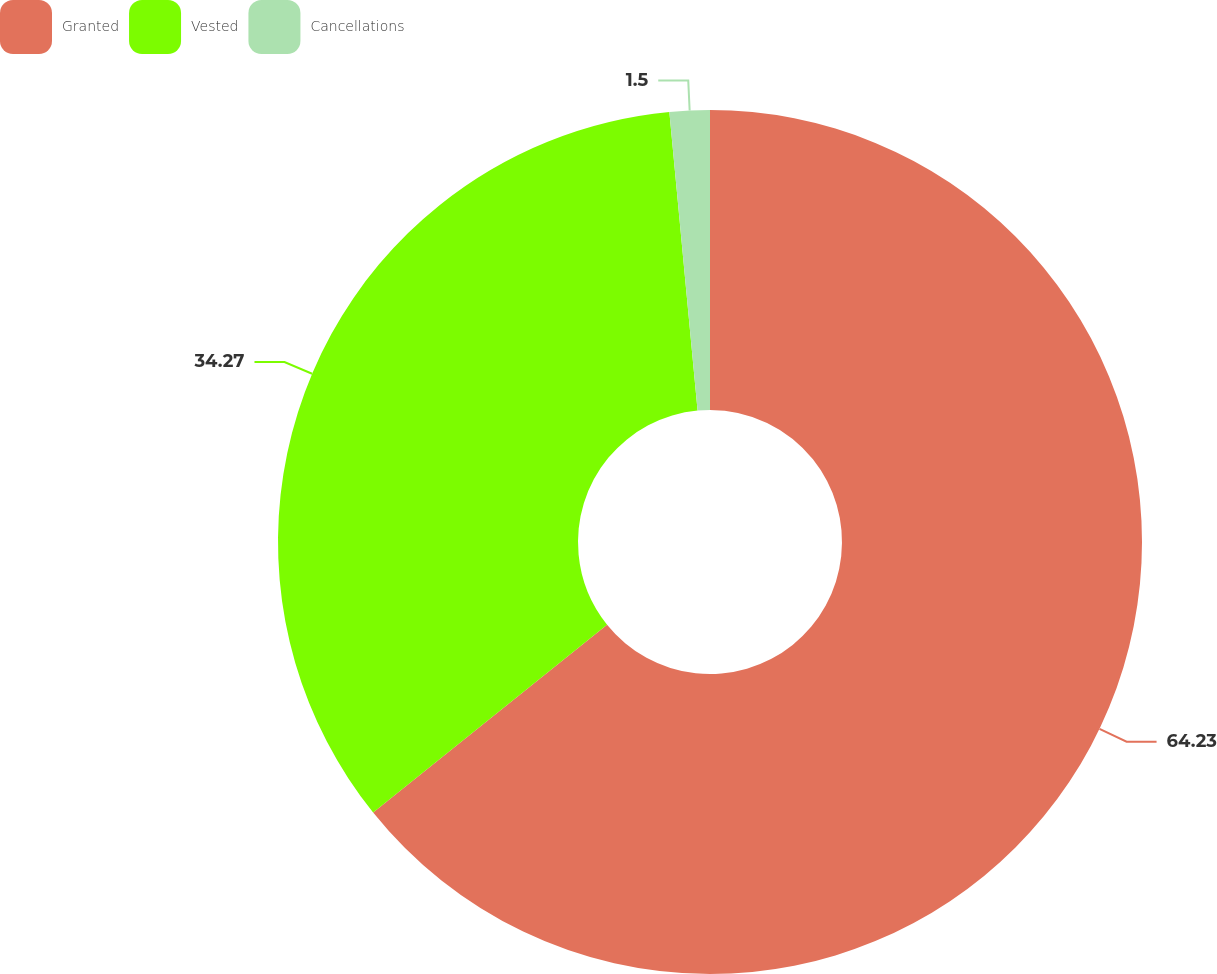Convert chart to OTSL. <chart><loc_0><loc_0><loc_500><loc_500><pie_chart><fcel>Granted<fcel>Vested<fcel>Cancellations<nl><fcel>64.24%<fcel>34.27%<fcel>1.5%<nl></chart> 